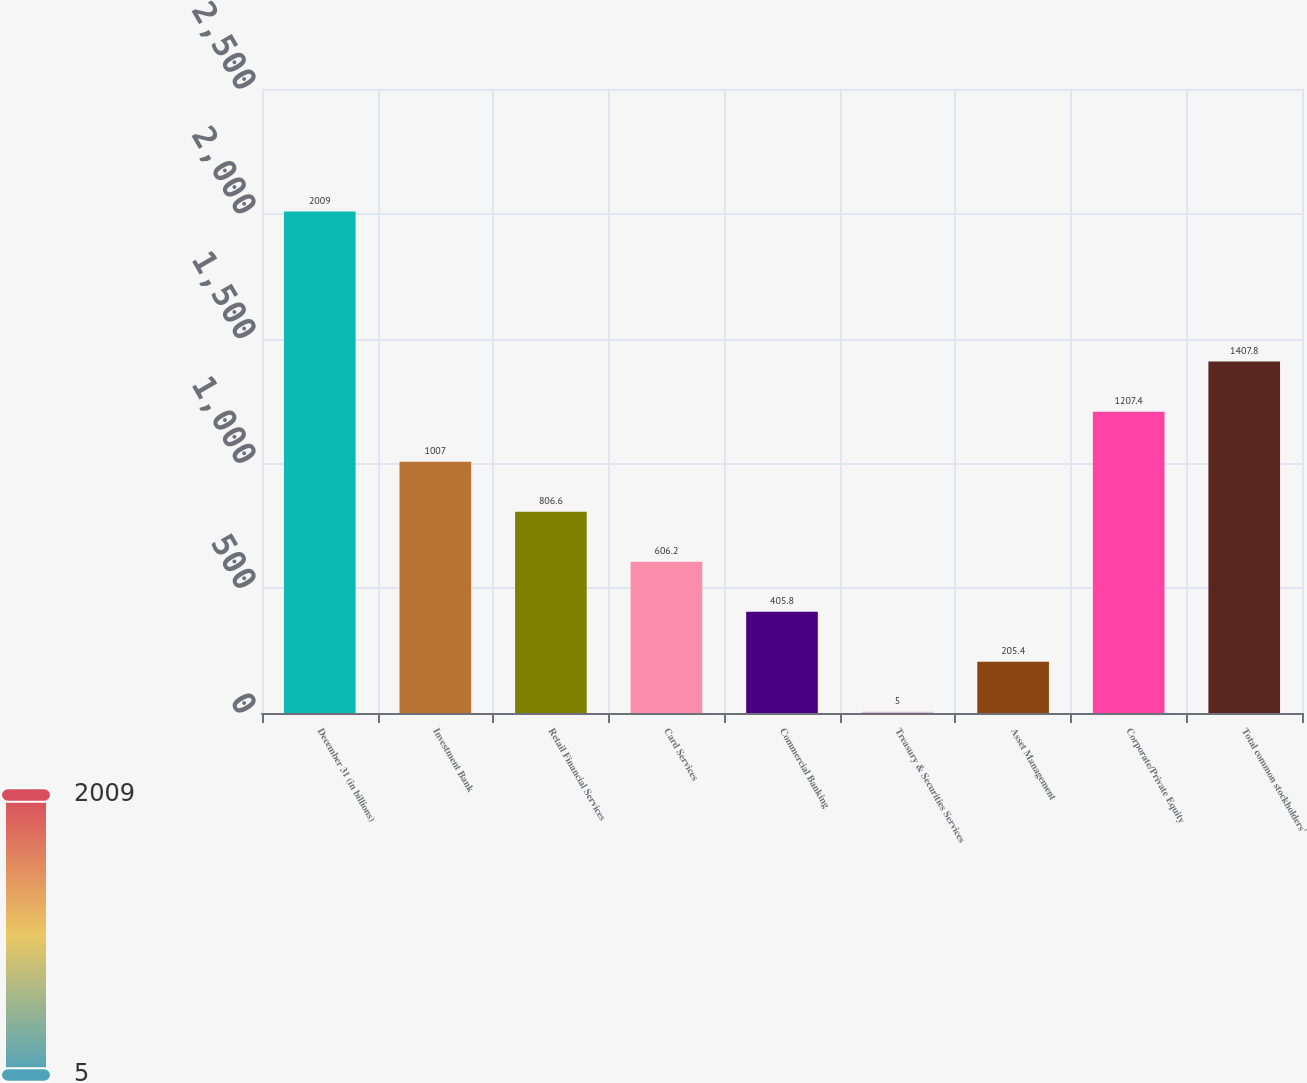Convert chart. <chart><loc_0><loc_0><loc_500><loc_500><bar_chart><fcel>December 31 (in billions)<fcel>Investment Bank<fcel>Retail Financial Services<fcel>Card Services<fcel>Commercial Banking<fcel>Treasury & Securities Services<fcel>Asset Management<fcel>Corporate/Private Equity<fcel>Total common stockholders'<nl><fcel>2009<fcel>1007<fcel>806.6<fcel>606.2<fcel>405.8<fcel>5<fcel>205.4<fcel>1207.4<fcel>1407.8<nl></chart> 